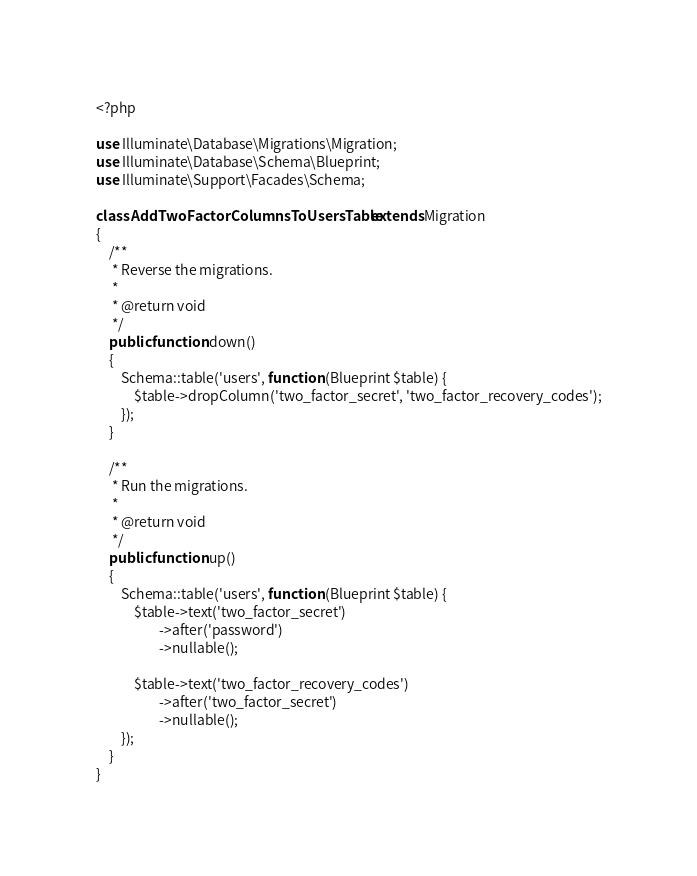Convert code to text. <code><loc_0><loc_0><loc_500><loc_500><_PHP_><?php

use Illuminate\Database\Migrations\Migration;
use Illuminate\Database\Schema\Blueprint;
use Illuminate\Support\Facades\Schema;

class AddTwoFactorColumnsToUsersTable extends Migration
{
    /**
     * Reverse the migrations.
     *
     * @return void
     */
    public function down()
    {
        Schema::table('users', function (Blueprint $table) {
            $table->dropColumn('two_factor_secret', 'two_factor_recovery_codes');
        });
    }

    /**
     * Run the migrations.
     *
     * @return void
     */
    public function up()
    {
        Schema::table('users', function (Blueprint $table) {
            $table->text('two_factor_secret')
                    ->after('password')
                    ->nullable();

            $table->text('two_factor_recovery_codes')
                    ->after('two_factor_secret')
                    ->nullable();
        });
    }
}
</code> 